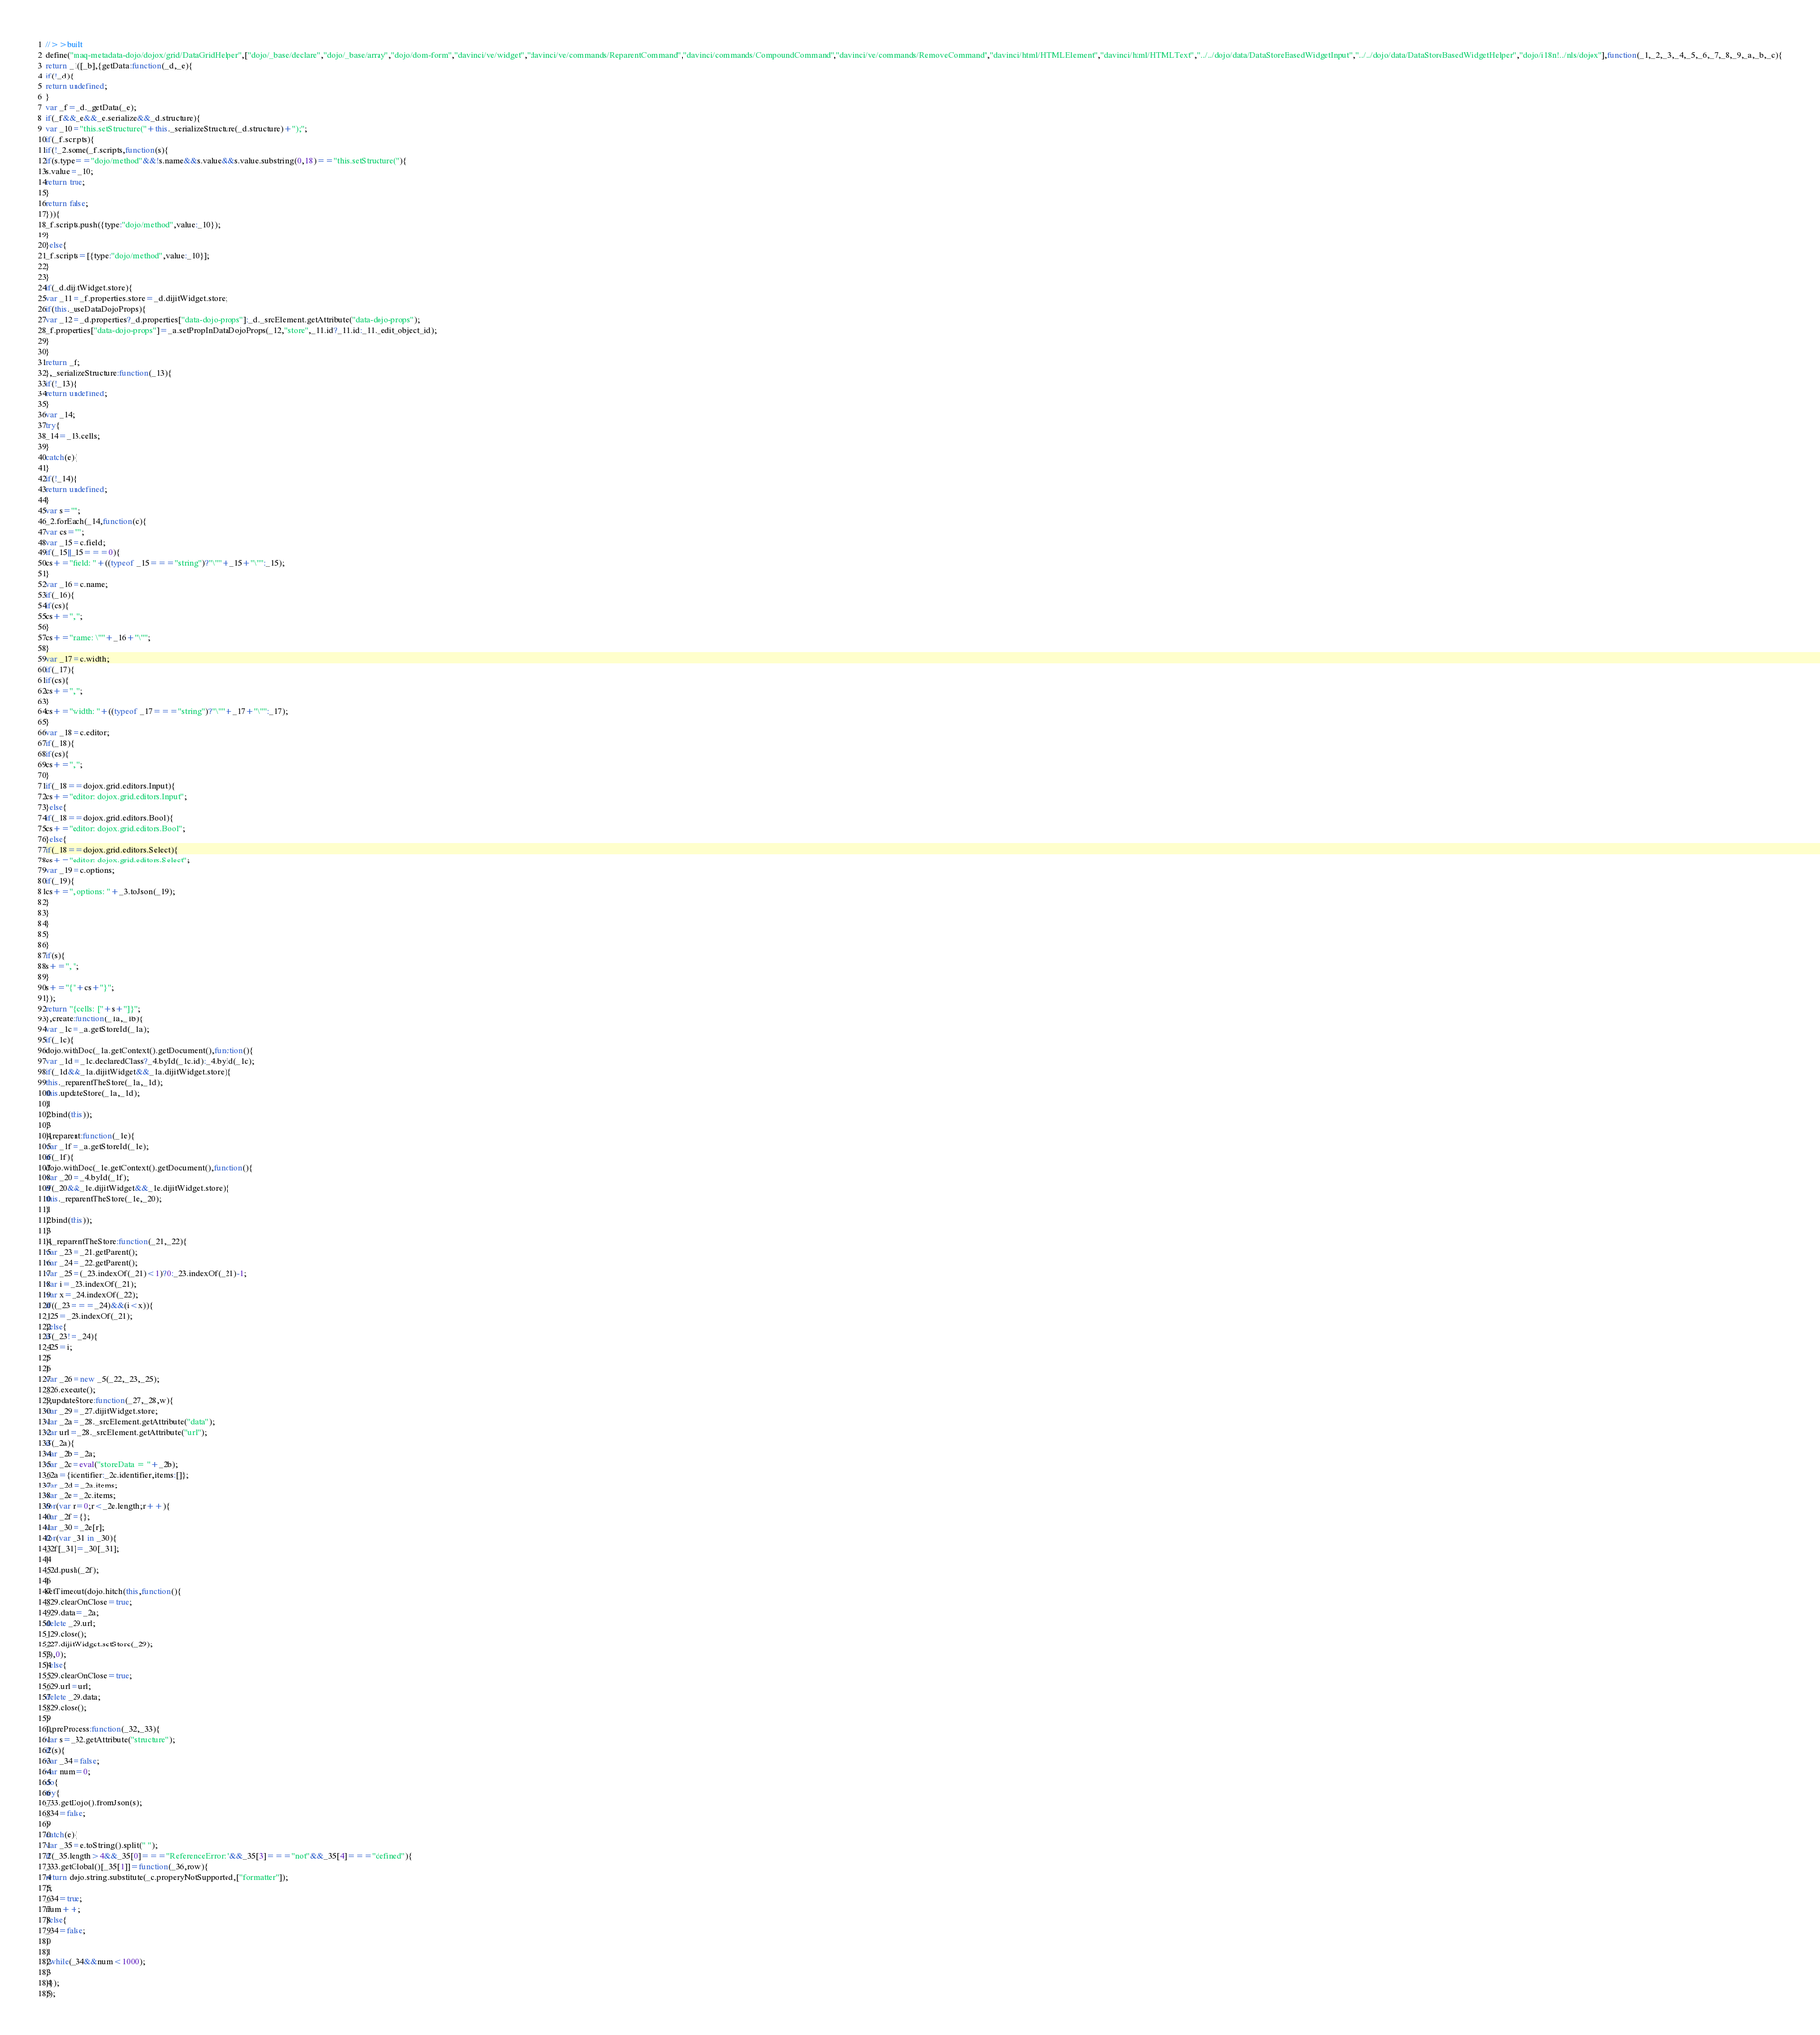Convert code to text. <code><loc_0><loc_0><loc_500><loc_500><_JavaScript_>//>>built
define("maq-metadata-dojo/dojox/grid/DataGridHelper",["dojo/_base/declare","dojo/_base/array","dojo/dom-form","davinci/ve/widget","davinci/ve/commands/ReparentCommand","davinci/commands/CompoundCommand","davinci/ve/commands/RemoveCommand","davinci/html/HTMLElement","davinci/html/HTMLText","../../dojo/data/DataStoreBasedWidgetInput","../../dojo/data/DataStoreBasedWidgetHelper","dojo/i18n!../nls/dojox"],function(_1,_2,_3,_4,_5,_6,_7,_8,_9,_a,_b,_c){
return _1([_b],{getData:function(_d,_e){
if(!_d){
return undefined;
}
var _f=_d._getData(_e);
if(_f&&_e&&_e.serialize&&_d.structure){
var _10="this.setStructure("+this._serializeStructure(_d.structure)+");";
if(_f.scripts){
if(!_2.some(_f.scripts,function(s){
if(s.type=="dojo/method"&&!s.name&&s.value&&s.value.substring(0,18)=="this.setStructure("){
s.value=_10;
return true;
}
return false;
})){
_f.scripts.push({type:"dojo/method",value:_10});
}
}else{
_f.scripts=[{type:"dojo/method",value:_10}];
}
}
if(_d.dijitWidget.store){
var _11=_f.properties.store=_d.dijitWidget.store;
if(this._useDataDojoProps){
var _12=_d.properties?_d.properties["data-dojo-props"]:_d._srcElement.getAttribute("data-dojo-props");
_f.properties["data-dojo-props"]=_a.setPropInDataDojoProps(_12,"store",_11.id?_11.id:_11._edit_object_id);
}
}
return _f;
},_serializeStructure:function(_13){
if(!_13){
return undefined;
}
var _14;
try{
_14=_13.cells;
}
catch(e){
}
if(!_14){
return undefined;
}
var s="";
_2.forEach(_14,function(c){
var cs="";
var _15=c.field;
if(_15||_15===0){
cs+="field: "+((typeof _15==="string")?"\""+_15+"\"":_15);
}
var _16=c.name;
if(_16){
if(cs){
cs+=", ";
}
cs+="name: \""+_16+"\"";
}
var _17=c.width;
if(_17){
if(cs){
cs+=", ";
}
cs+="width: "+((typeof _17==="string")?"\""+_17+"\"":_17);
}
var _18=c.editor;
if(_18){
if(cs){
cs+=", ";
}
if(_18==dojox.grid.editors.Input){
cs+="editor: dojox.grid.editors.Input";
}else{
if(_18==dojox.grid.editors.Bool){
cs+="editor: dojox.grid.editors.Bool";
}else{
if(_18==dojox.grid.editors.Select){
cs+="editor: dojox.grid.editors.Select";
var _19=c.options;
if(_19){
cs+=", options: "+_3.toJson(_19);
}
}
}
}
}
if(s){
s+=", ";
}
s+="{"+cs+"}";
});
return "{cells: ["+s+"]}";
},create:function(_1a,_1b){
var _1c=_a.getStoreId(_1a);
if(_1c){
dojo.withDoc(_1a.getContext().getDocument(),function(){
var _1d=_1c.declaredClass?_4.byId(_1c.id):_4.byId(_1c);
if(_1d&&_1a.dijitWidget&&_1a.dijitWidget.store){
this._reparentTheStore(_1a,_1d);
this.updateStore(_1a,_1d);
}
}.bind(this));
}
},reparent:function(_1e){
var _1f=_a.getStoreId(_1e);
if(_1f){
dojo.withDoc(_1e.getContext().getDocument(),function(){
var _20=_4.byId(_1f);
if(_20&&_1e.dijitWidget&&_1e.dijitWidget.store){
this._reparentTheStore(_1e,_20);
}
}.bind(this));
}
},_reparentTheStore:function(_21,_22){
var _23=_21.getParent();
var _24=_22.getParent();
var _25=(_23.indexOf(_21)<1)?0:_23.indexOf(_21)-1;
var i=_23.indexOf(_21);
var x=_24.indexOf(_22);
if((_23===_24)&&(i<x)){
_25=_23.indexOf(_21);
}else{
if(_23!=_24){
_25=i;
}
}
var _26=new _5(_22,_23,_25);
_26.execute();
},updateStore:function(_27,_28,w){
var _29=_27.dijitWidget.store;
var _2a=_28._srcElement.getAttribute("data");
var url=_28._srcElement.getAttribute("url");
if(_2a){
var _2b=_2a;
var _2c=eval("storeData = "+_2b);
_2a={identifier:_2c.identifier,items:[]};
var _2d=_2a.items;
var _2e=_2c.items;
for(var r=0;r<_2e.length;r++){
var _2f={};
var _30=_2e[r];
for(var _31 in _30){
_2f[_31]=_30[_31];
}
_2d.push(_2f);
}
setTimeout(dojo.hitch(this,function(){
_29.clearOnClose=true;
_29.data=_2a;
delete _29.url;
_29.close();
_27.dijitWidget.setStore(_29);
}),0);
}else{
_29.clearOnClose=true;
_29.url=url;
delete _29.data;
_29.close();
}
},preProcess:function(_32,_33){
var s=_32.getAttribute("structure");
if(s){
var _34=false;
var num=0;
do{
try{
_33.getDojo().fromJson(s);
_34=false;
}
catch(e){
var _35=e.toString().split(" ");
if(_35.length>4&&_35[0]==="ReferenceError:"&&_35[3]==="not"&&_35[4]==="defined"){
_33.getGlobal()[_35[1]]=function(_36,row){
return dojo.string.substitute(_c.properyNotSupported,["formatter"]);
};
_34=true;
num++;
}else{
_34=false;
}
}
}while(_34&&num<1000);
}
}});
});
</code> 